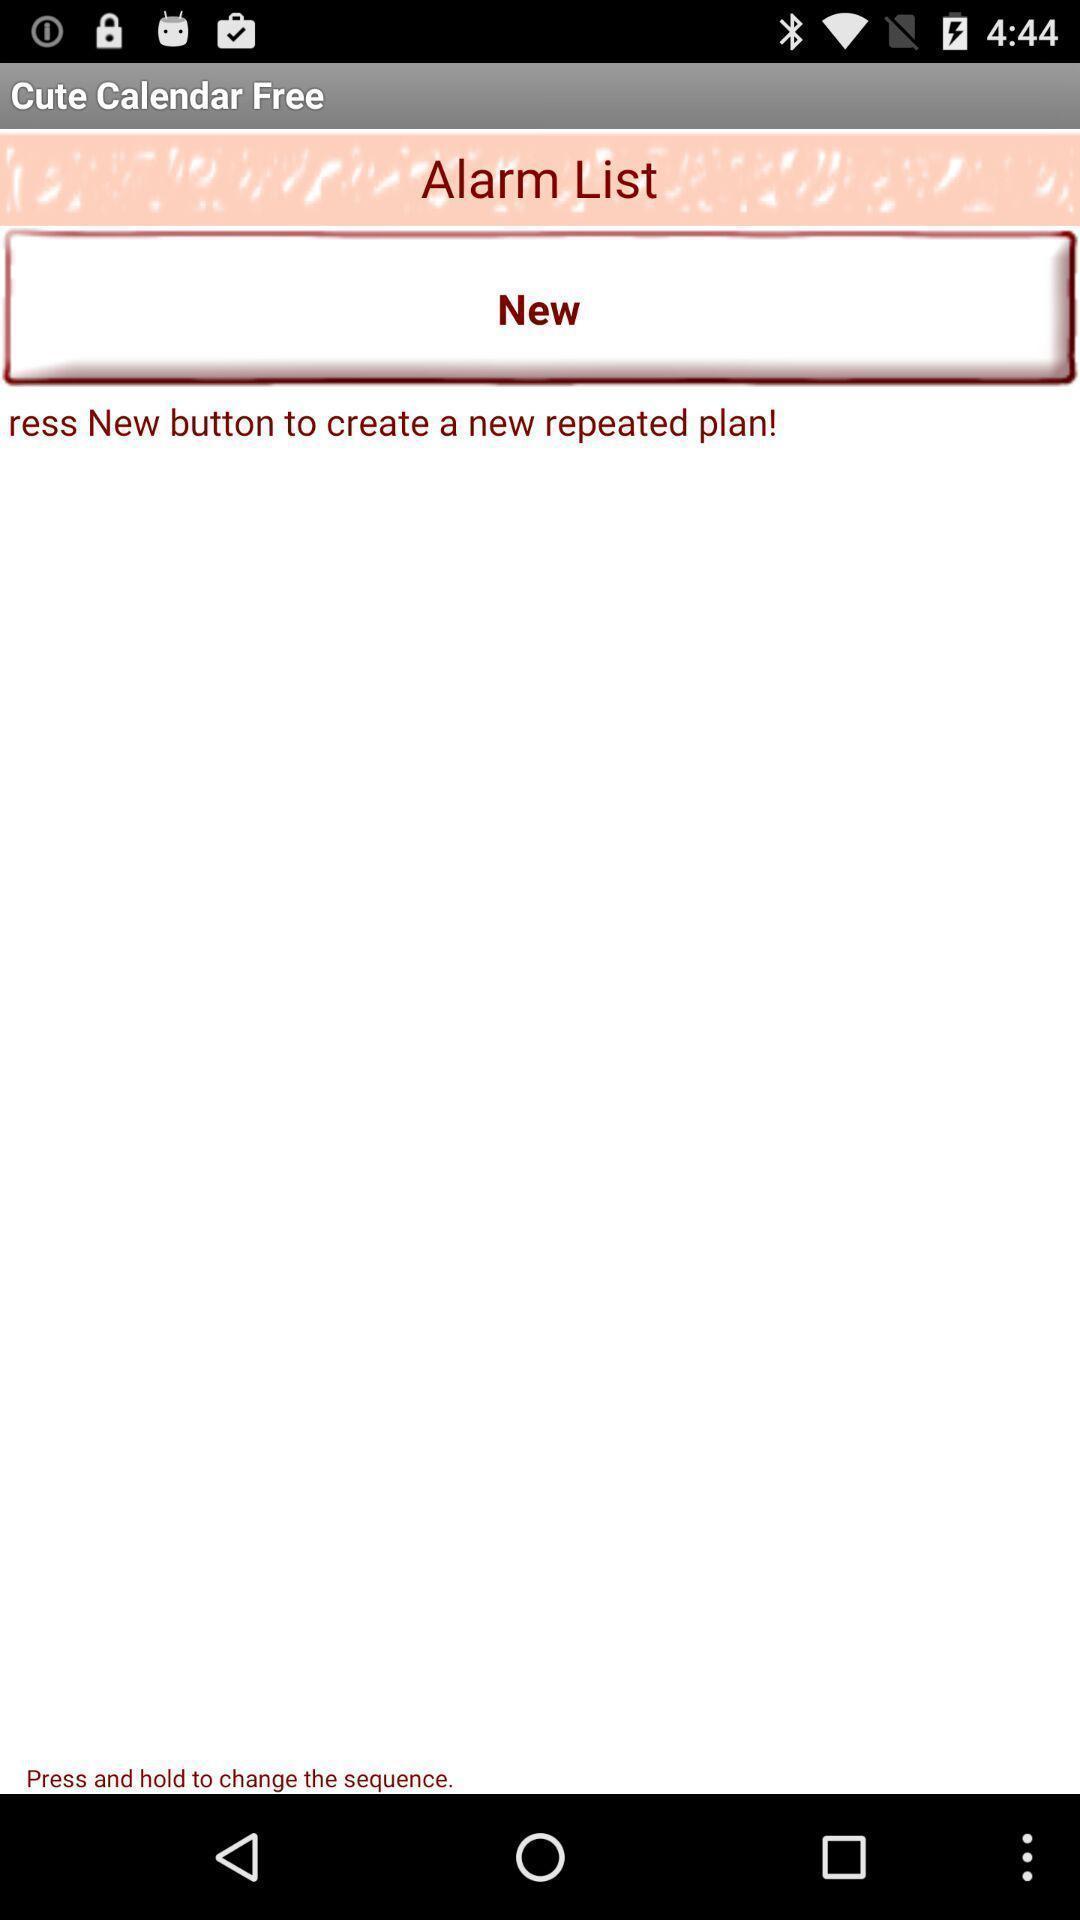What details can you identify in this image? Page showing a variety of alarm. 